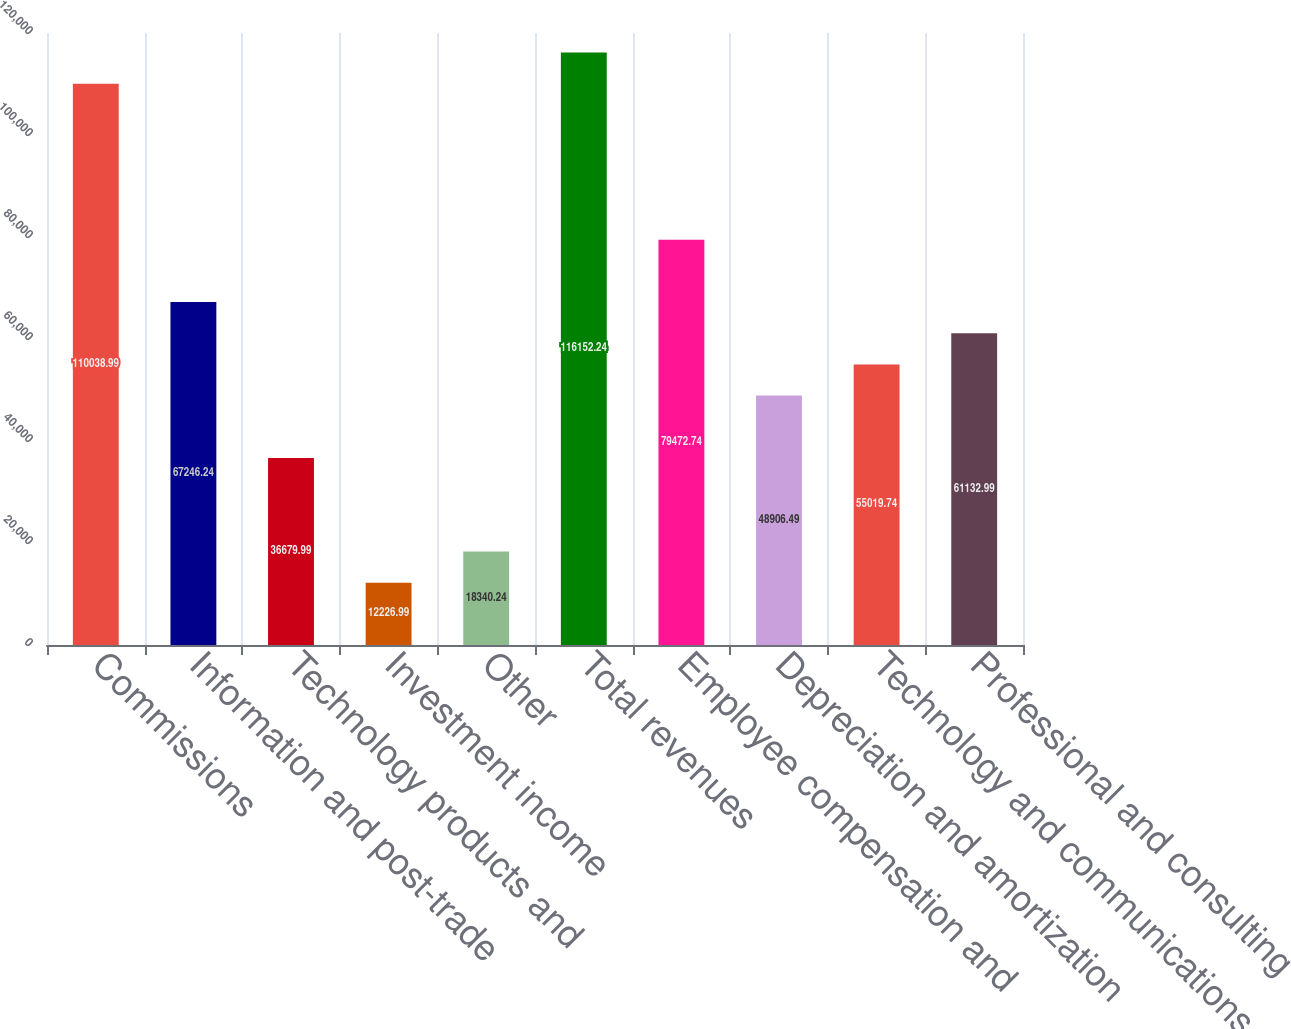Convert chart to OTSL. <chart><loc_0><loc_0><loc_500><loc_500><bar_chart><fcel>Commissions<fcel>Information and post-trade<fcel>Technology products and<fcel>Investment income<fcel>Other<fcel>Total revenues<fcel>Employee compensation and<fcel>Depreciation and amortization<fcel>Technology and communications<fcel>Professional and consulting<nl><fcel>110039<fcel>67246.2<fcel>36680<fcel>12227<fcel>18340.2<fcel>116152<fcel>79472.7<fcel>48906.5<fcel>55019.7<fcel>61133<nl></chart> 